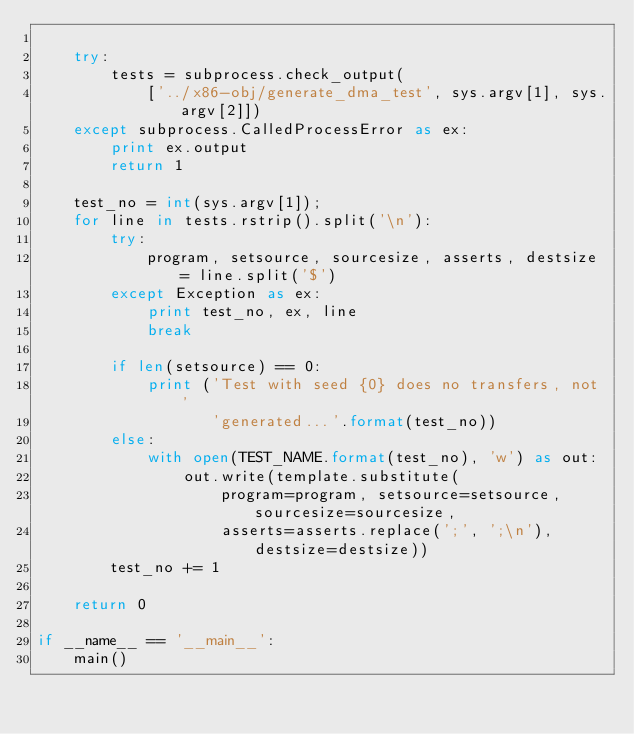<code> <loc_0><loc_0><loc_500><loc_500><_Python_>
    try:
        tests = subprocess.check_output(
            ['../x86-obj/generate_dma_test', sys.argv[1], sys.argv[2]])
    except subprocess.CalledProcessError as ex:
        print ex.output
        return 1

    test_no = int(sys.argv[1]);
    for line in tests.rstrip().split('\n'):
        try:
            program, setsource, sourcesize, asserts, destsize = line.split('$')
        except Exception as ex:
            print test_no, ex, line
            break

        if len(setsource) == 0:
            print ('Test with seed {0} does no transfers, not '
                   'generated...'.format(test_no))
        else:
            with open(TEST_NAME.format(test_no), 'w') as out:
                out.write(template.substitute(
                    program=program, setsource=setsource, sourcesize=sourcesize,
                    asserts=asserts.replace(';', ';\n'), destsize=destsize))
        test_no += 1

    return 0

if __name__ == '__main__':
    main()
</code> 